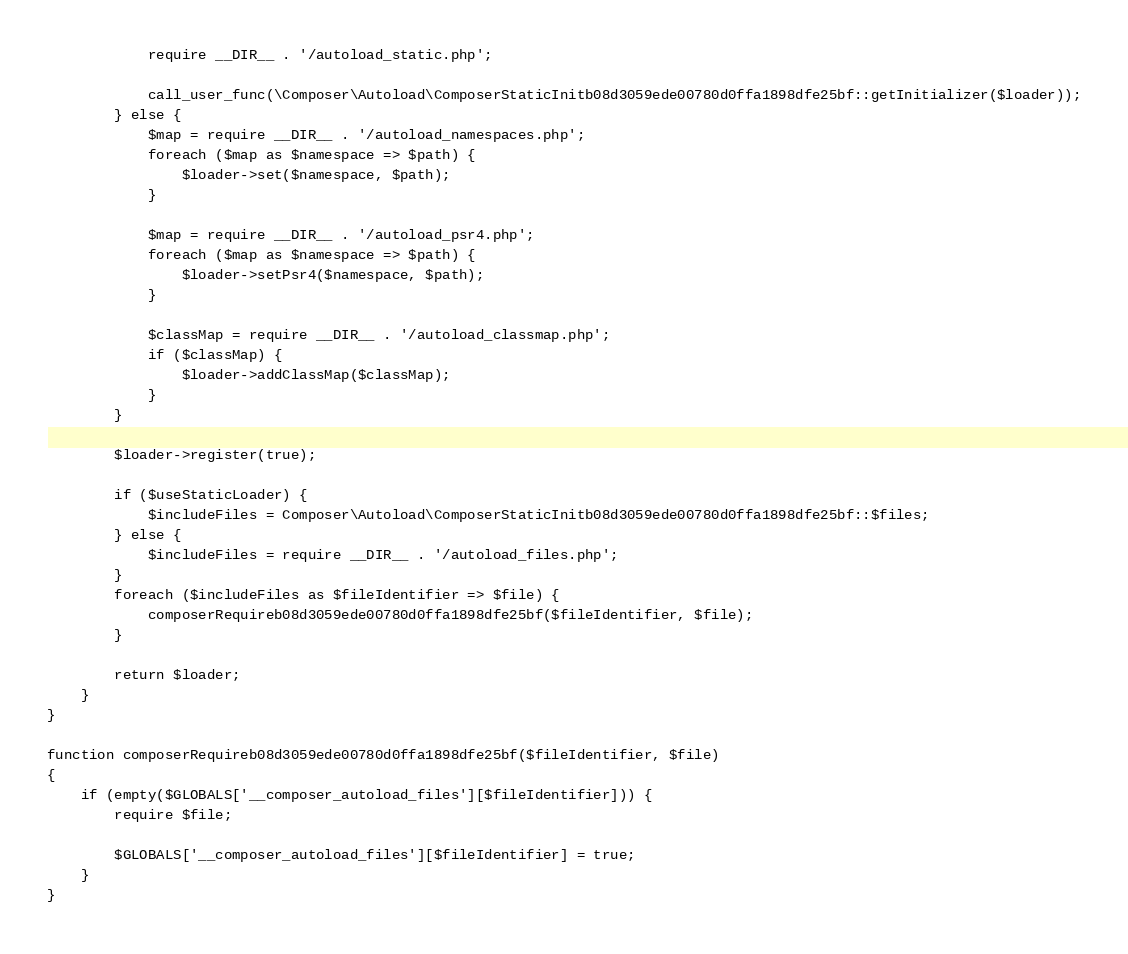Convert code to text. <code><loc_0><loc_0><loc_500><loc_500><_PHP_>            require __DIR__ . '/autoload_static.php';

            call_user_func(\Composer\Autoload\ComposerStaticInitb08d3059ede00780d0ffa1898dfe25bf::getInitializer($loader));
        } else {
            $map = require __DIR__ . '/autoload_namespaces.php';
            foreach ($map as $namespace => $path) {
                $loader->set($namespace, $path);
            }

            $map = require __DIR__ . '/autoload_psr4.php';
            foreach ($map as $namespace => $path) {
                $loader->setPsr4($namespace, $path);
            }

            $classMap = require __DIR__ . '/autoload_classmap.php';
            if ($classMap) {
                $loader->addClassMap($classMap);
            }
        }

        $loader->register(true);

        if ($useStaticLoader) {
            $includeFiles = Composer\Autoload\ComposerStaticInitb08d3059ede00780d0ffa1898dfe25bf::$files;
        } else {
            $includeFiles = require __DIR__ . '/autoload_files.php';
        }
        foreach ($includeFiles as $fileIdentifier => $file) {
            composerRequireb08d3059ede00780d0ffa1898dfe25bf($fileIdentifier, $file);
        }

        return $loader;
    }
}

function composerRequireb08d3059ede00780d0ffa1898dfe25bf($fileIdentifier, $file)
{
    if (empty($GLOBALS['__composer_autoload_files'][$fileIdentifier])) {
        require $file;

        $GLOBALS['__composer_autoload_files'][$fileIdentifier] = true;
    }
}
</code> 